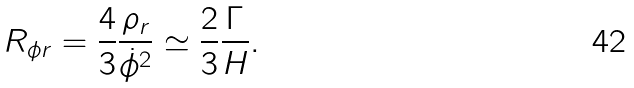<formula> <loc_0><loc_0><loc_500><loc_500>R _ { \phi r } = \frac { 4 } { 3 } \frac { \rho _ { r } } { \dot { \phi } ^ { 2 } } \simeq \frac { 2 } { 3 } \frac { \Gamma } { H } .</formula> 